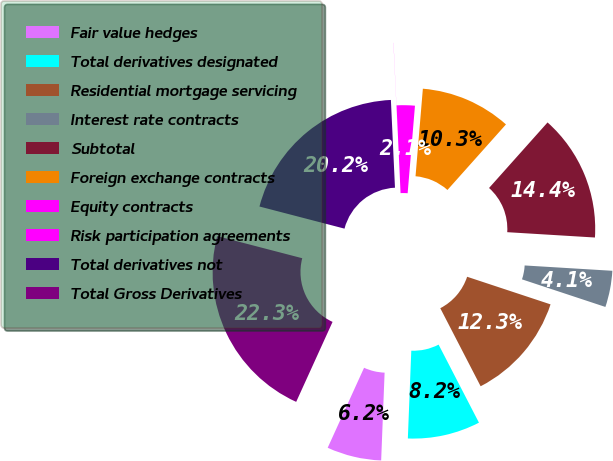Convert chart. <chart><loc_0><loc_0><loc_500><loc_500><pie_chart><fcel>Fair value hedges<fcel>Total derivatives designated<fcel>Residential mortgage servicing<fcel>Interest rate contracts<fcel>Subtotal<fcel>Foreign exchange contracts<fcel>Equity contracts<fcel>Risk participation agreements<fcel>Total derivatives not<fcel>Total Gross Derivatives<nl><fcel>6.17%<fcel>8.22%<fcel>12.32%<fcel>4.12%<fcel>14.37%<fcel>10.27%<fcel>2.06%<fcel>0.01%<fcel>20.21%<fcel>22.26%<nl></chart> 